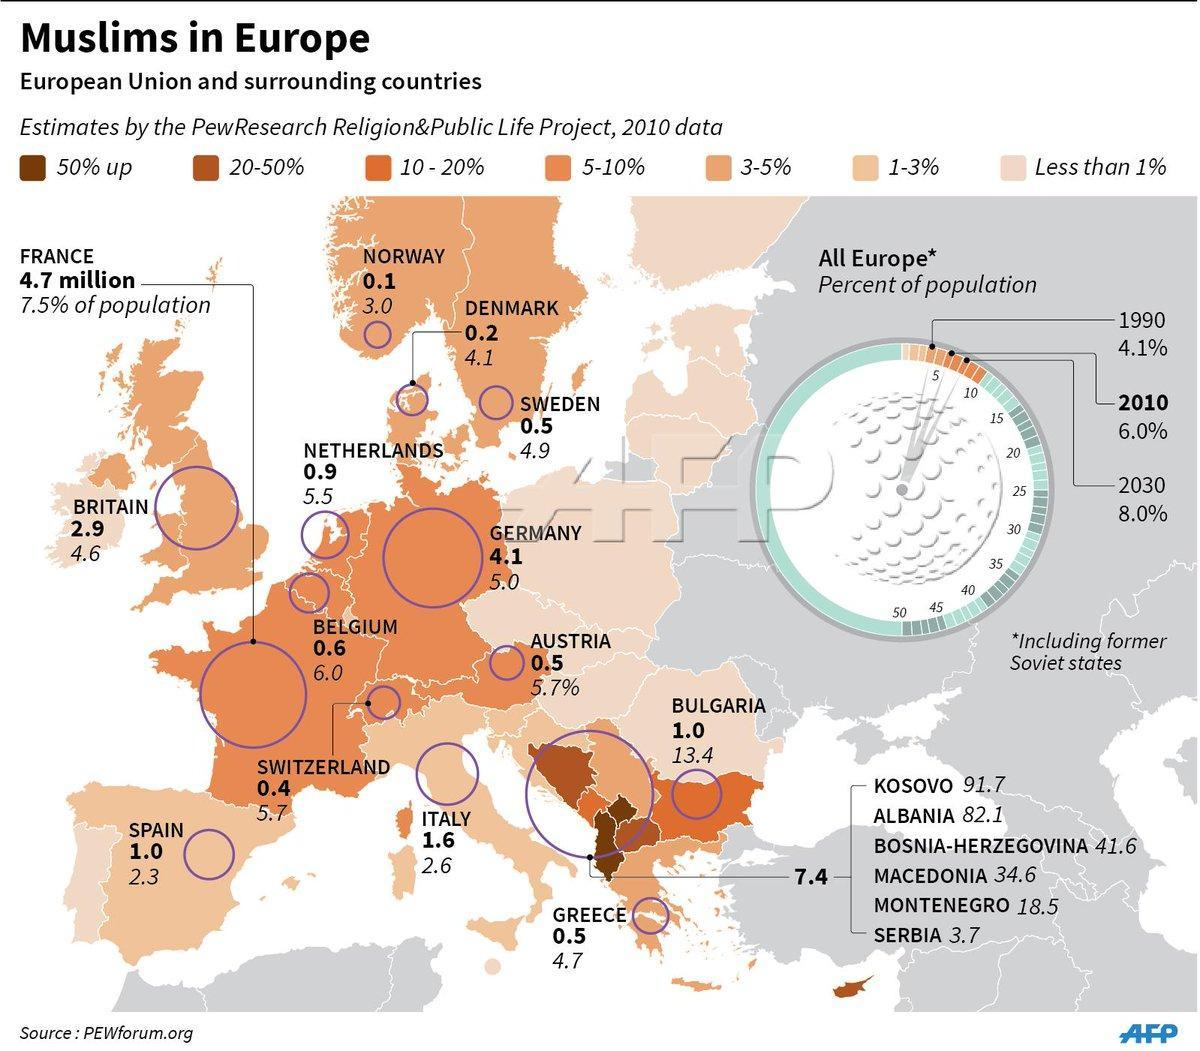Muslim population of which country is higher - Netherlands or Germany?
Answer the question with a short phrase. Germany what is the total Muslim population from Germany and Austria taken together in millions? 4.6 what percent of people of Italy are Muslims? 2.6 what is the total Muslim population from Italy and Greece taken together in millions? 2.1 Muslim population of which country is higher - Britain or Italy? Britain what is the Muslim population of Austria in millions? 0.5 what is the Muslim population of Germany in millions? 4.1 what is the total Muslim population from Spain and Greece taken together in millions? 1.5 what is the Muslim population of Denmark in millions? 0.2 what is the total Muslim population from Norway, Denmark and Sweden taken together in millions? 0.8 what is the Muslim population of Switzerland in millions? 0.4 what is the total Muslim population from Britain and France taken together in millions? 7.6 what percent of people of Belgium are Muslims? 6 what is the Muslim population of Sweden in  millions? 0.5 what percent of people of Norway are Muslims? 3 